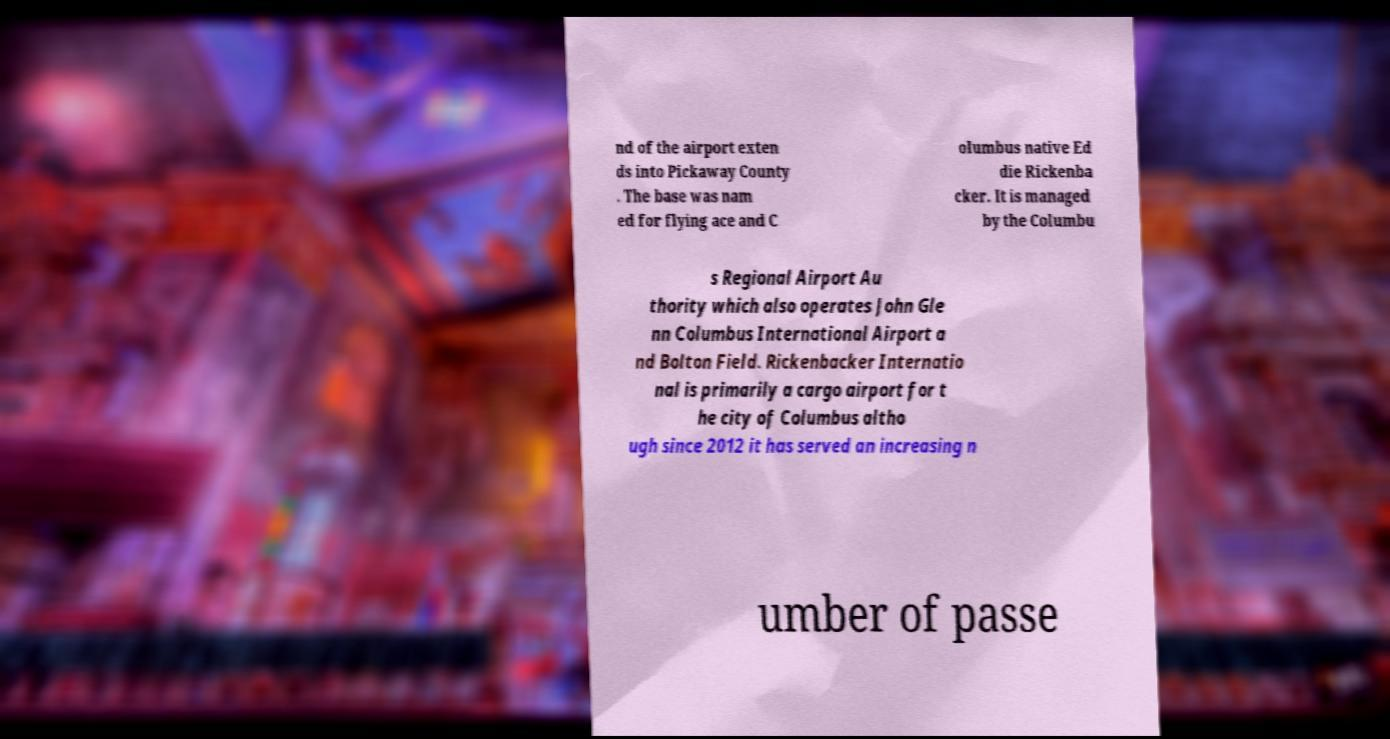Please read and relay the text visible in this image. What does it say? nd of the airport exten ds into Pickaway County . The base was nam ed for flying ace and C olumbus native Ed die Rickenba cker. It is managed by the Columbu s Regional Airport Au thority which also operates John Gle nn Columbus International Airport a nd Bolton Field. Rickenbacker Internatio nal is primarily a cargo airport for t he city of Columbus altho ugh since 2012 it has served an increasing n umber of passe 